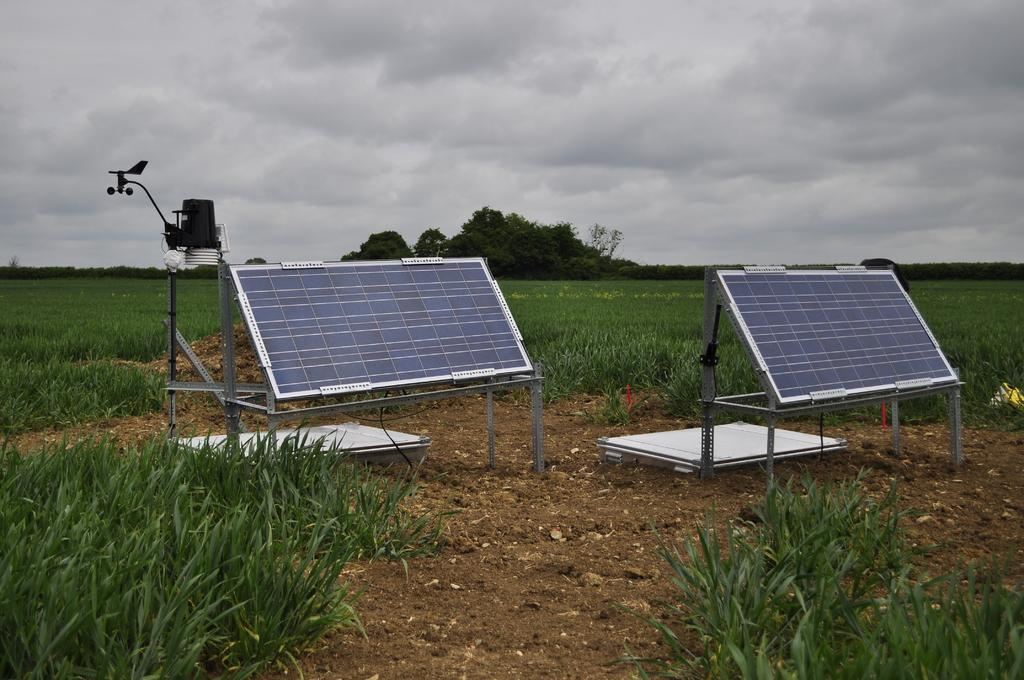What can be seen in the sky in the image? The sky is visible in the image, and there are clouds present. What type of vegetation is in the image? There are trees in the image, and grass is also present. What is visible on the ground in the image? The ground is visible in the image, and solar plates are present. Where is the camp located in the image? There is no camp present in the image. What type of bath can be seen in the image in the image? There is no bath present in the image. 